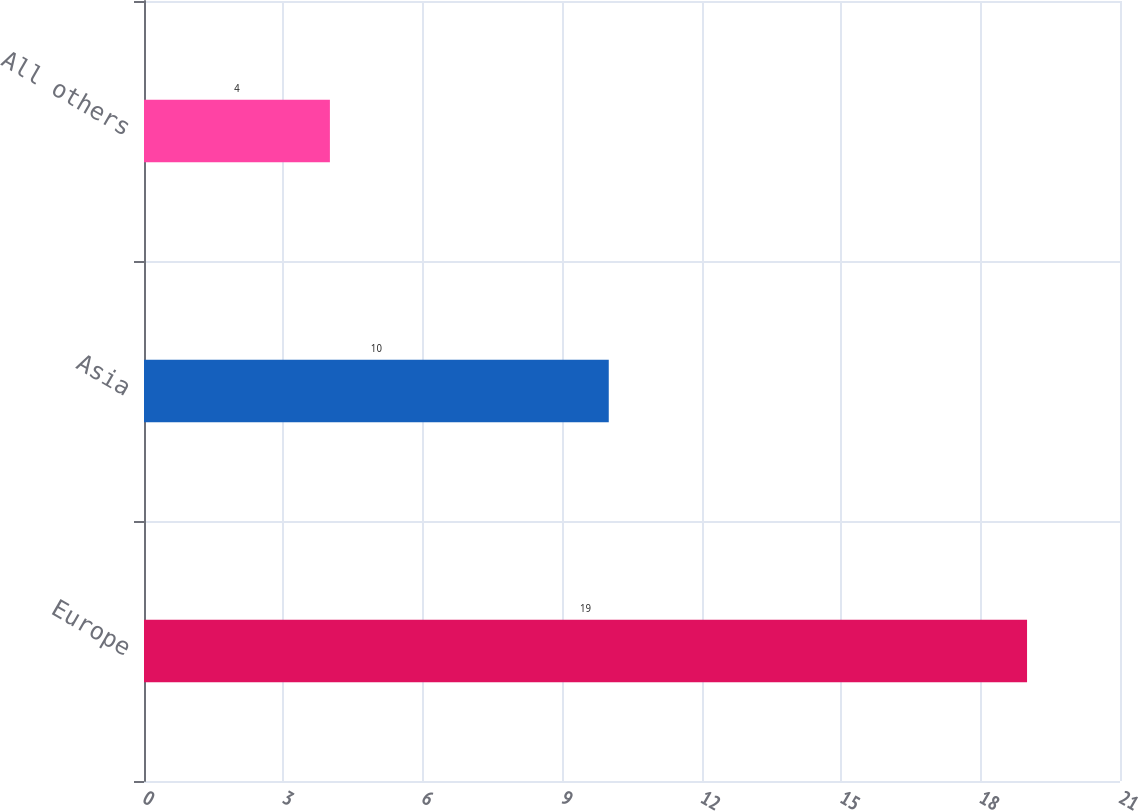Convert chart. <chart><loc_0><loc_0><loc_500><loc_500><bar_chart><fcel>Europe<fcel>Asia<fcel>All others<nl><fcel>19<fcel>10<fcel>4<nl></chart> 